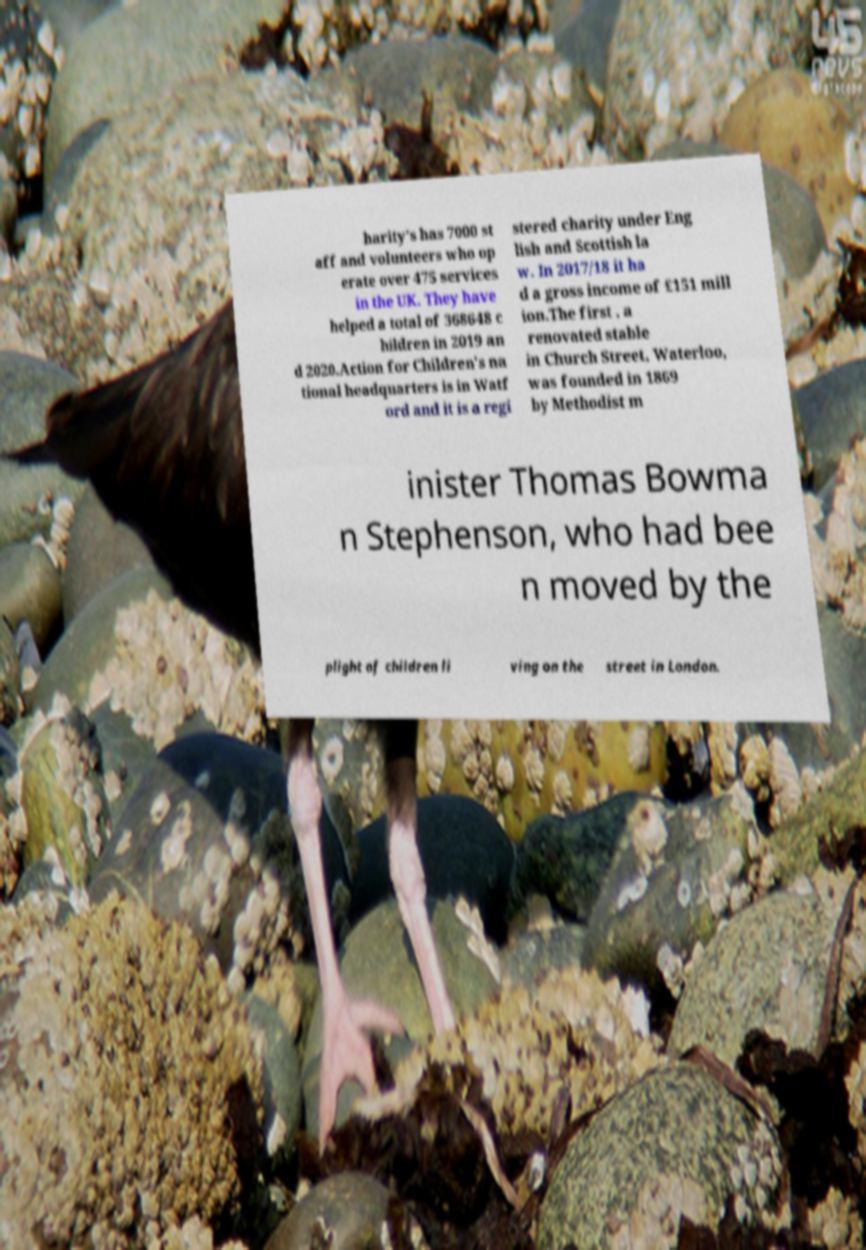Could you assist in decoding the text presented in this image and type it out clearly? harity's has 7000 st aff and volunteers who op erate over 475 services in the UK. They have helped a total of 368648 c hildren in 2019 an d 2020.Action for Children's na tional headquarters is in Watf ord and it is a regi stered charity under Eng lish and Scottish la w. In 2017/18 it ha d a gross income of £151 mill ion.The first , a renovated stable in Church Street, Waterloo, was founded in 1869 by Methodist m inister Thomas Bowma n Stephenson, who had bee n moved by the plight of children li ving on the street in London. 